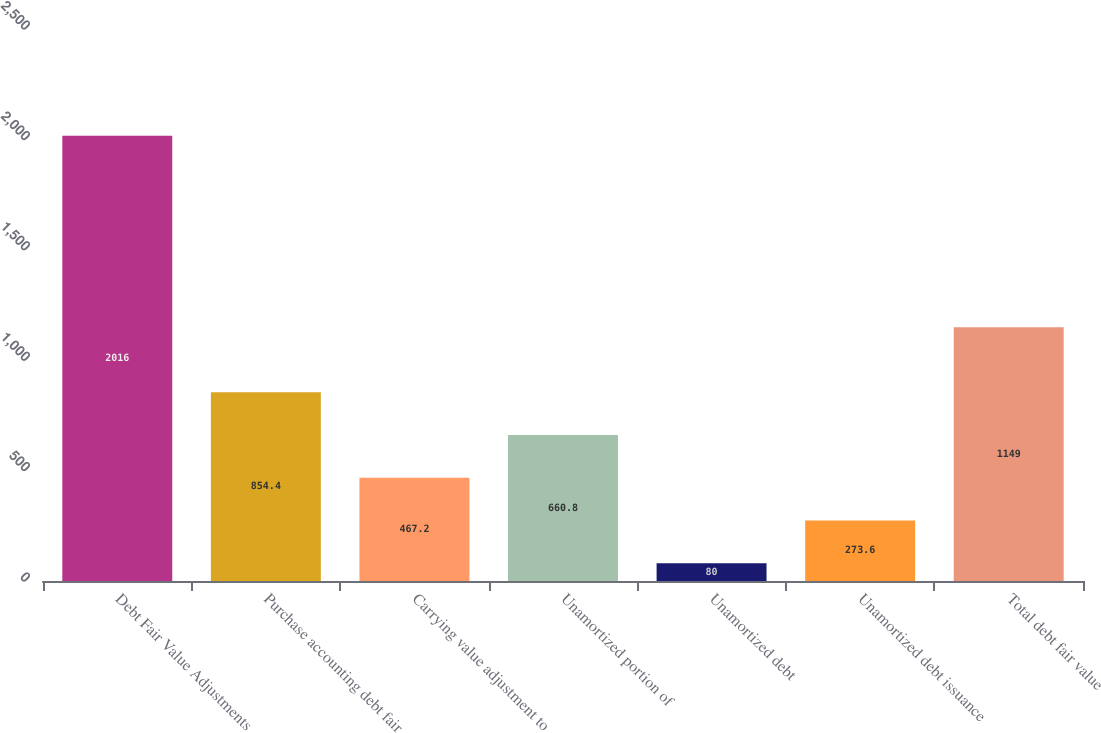Convert chart. <chart><loc_0><loc_0><loc_500><loc_500><bar_chart><fcel>Debt Fair Value Adjustments<fcel>Purchase accounting debt fair<fcel>Carrying value adjustment to<fcel>Unamortized portion of<fcel>Unamortized debt<fcel>Unamortized debt issuance<fcel>Total debt fair value<nl><fcel>2016<fcel>854.4<fcel>467.2<fcel>660.8<fcel>80<fcel>273.6<fcel>1149<nl></chart> 